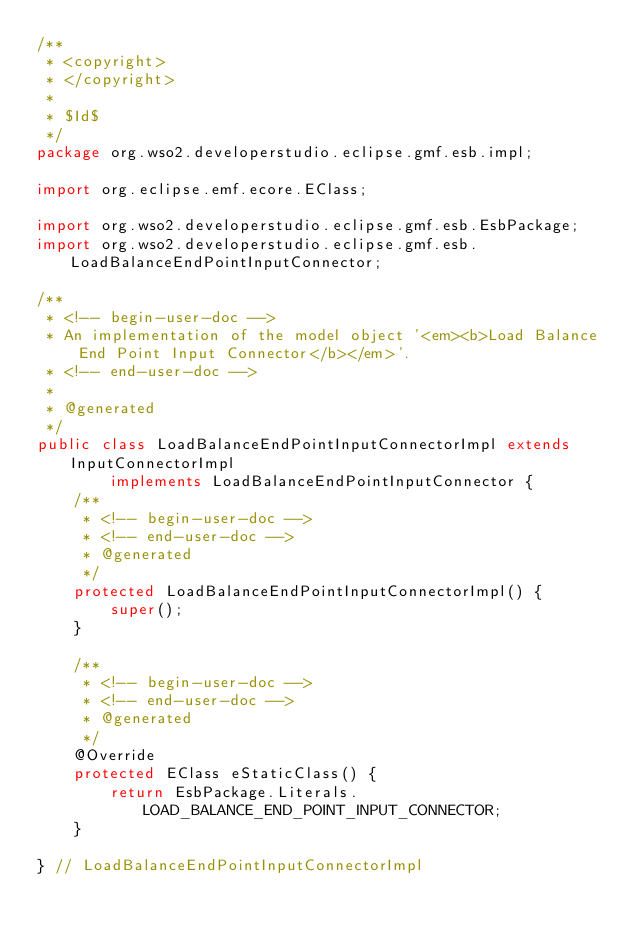<code> <loc_0><loc_0><loc_500><loc_500><_Java_>/**
 * <copyright>
 * </copyright>
 *
 * $Id$
 */
package org.wso2.developerstudio.eclipse.gmf.esb.impl;

import org.eclipse.emf.ecore.EClass;

import org.wso2.developerstudio.eclipse.gmf.esb.EsbPackage;
import org.wso2.developerstudio.eclipse.gmf.esb.LoadBalanceEndPointInputConnector;

/**
 * <!-- begin-user-doc -->
 * An implementation of the model object '<em><b>Load Balance End Point Input Connector</b></em>'.
 * <!-- end-user-doc -->
 *
 * @generated
 */
public class LoadBalanceEndPointInputConnectorImpl extends InputConnectorImpl
        implements LoadBalanceEndPointInputConnector {
    /**
     * <!-- begin-user-doc -->
     * <!-- end-user-doc -->
     * @generated
     */
    protected LoadBalanceEndPointInputConnectorImpl() {
        super();
    }

    /**
     * <!-- begin-user-doc -->
     * <!-- end-user-doc -->
     * @generated
     */
    @Override
    protected EClass eStaticClass() {
        return EsbPackage.Literals.LOAD_BALANCE_END_POINT_INPUT_CONNECTOR;
    }

} // LoadBalanceEndPointInputConnectorImpl
</code> 